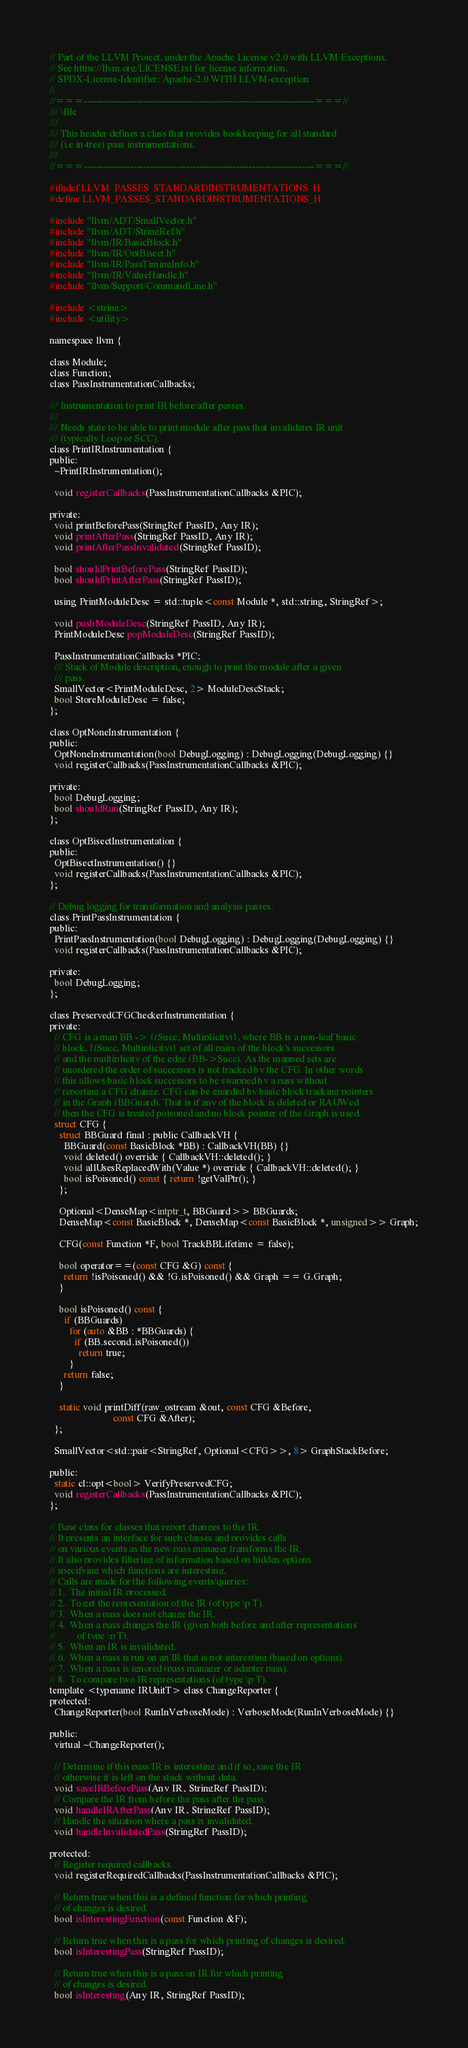Convert code to text. <code><loc_0><loc_0><loc_500><loc_500><_C_>// Part of the LLVM Project, under the Apache License v2.0 with LLVM Exceptions.
// See https://llvm.org/LICENSE.txt for license information.
// SPDX-License-Identifier: Apache-2.0 WITH LLVM-exception
//
//===----------------------------------------------------------------------===//
/// \file
///
/// This header defines a class that provides bookkeeping for all standard
/// (i.e in-tree) pass instrumentations.
///
//===----------------------------------------------------------------------===//

#ifndef LLVM_PASSES_STANDARDINSTRUMENTATIONS_H
#define LLVM_PASSES_STANDARDINSTRUMENTATIONS_H

#include "llvm/ADT/SmallVector.h"
#include "llvm/ADT/StringRef.h"
#include "llvm/IR/BasicBlock.h"
#include "llvm/IR/OptBisect.h"
#include "llvm/IR/PassTimingInfo.h"
#include "llvm/IR/ValueHandle.h"
#include "llvm/Support/CommandLine.h"

#include <string>
#include <utility>

namespace llvm {

class Module;
class Function;
class PassInstrumentationCallbacks;

/// Instrumentation to print IR before/after passes.
///
/// Needs state to be able to print module after pass that invalidates IR unit
/// (typically Loop or SCC).
class PrintIRInstrumentation {
public:
  ~PrintIRInstrumentation();

  void registerCallbacks(PassInstrumentationCallbacks &PIC);

private:
  void printBeforePass(StringRef PassID, Any IR);
  void printAfterPass(StringRef PassID, Any IR);
  void printAfterPassInvalidated(StringRef PassID);

  bool shouldPrintBeforePass(StringRef PassID);
  bool shouldPrintAfterPass(StringRef PassID);

  using PrintModuleDesc = std::tuple<const Module *, std::string, StringRef>;

  void pushModuleDesc(StringRef PassID, Any IR);
  PrintModuleDesc popModuleDesc(StringRef PassID);

  PassInstrumentationCallbacks *PIC;
  /// Stack of Module description, enough to print the module after a given
  /// pass.
  SmallVector<PrintModuleDesc, 2> ModuleDescStack;
  bool StoreModuleDesc = false;
};

class OptNoneInstrumentation {
public:
  OptNoneInstrumentation(bool DebugLogging) : DebugLogging(DebugLogging) {}
  void registerCallbacks(PassInstrumentationCallbacks &PIC);

private:
  bool DebugLogging;
  bool shouldRun(StringRef PassID, Any IR);
};

class OptBisectInstrumentation {
public:
  OptBisectInstrumentation() {}
  void registerCallbacks(PassInstrumentationCallbacks &PIC);
};

// Debug logging for transformation and analysis passes.
class PrintPassInstrumentation {
public:
  PrintPassInstrumentation(bool DebugLogging) : DebugLogging(DebugLogging) {}
  void registerCallbacks(PassInstrumentationCallbacks &PIC);

private:
  bool DebugLogging;
};

class PreservedCFGCheckerInstrumentation {
private:
  // CFG is a map BB -> {(Succ, Multiplicity)}, where BB is a non-leaf basic
  // block, {(Succ, Multiplicity)} set of all pairs of the block's successors
  // and the multiplicity of the edge (BB->Succ). As the mapped sets are
  // unordered the order of successors is not tracked by the CFG. In other words
  // this allows basic block successors to be swapped by a pass without
  // reporting a CFG change. CFG can be guarded by basic block tracking pointers
  // in the Graph (BBGuard). That is if any of the block is deleted or RAUWed
  // then the CFG is treated poisoned and no block pointer of the Graph is used.
  struct CFG {
    struct BBGuard final : public CallbackVH {
      BBGuard(const BasicBlock *BB) : CallbackVH(BB) {}
      void deleted() override { CallbackVH::deleted(); }
      void allUsesReplacedWith(Value *) override { CallbackVH::deleted(); }
      bool isPoisoned() const { return !getValPtr(); }
    };

    Optional<DenseMap<intptr_t, BBGuard>> BBGuards;
    DenseMap<const BasicBlock *, DenseMap<const BasicBlock *, unsigned>> Graph;

    CFG(const Function *F, bool TrackBBLifetime = false);

    bool operator==(const CFG &G) const {
      return !isPoisoned() && !G.isPoisoned() && Graph == G.Graph;
    }

    bool isPoisoned() const {
      if (BBGuards)
        for (auto &BB : *BBGuards) {
          if (BB.second.isPoisoned())
            return true;
        }
      return false;
    }

    static void printDiff(raw_ostream &out, const CFG &Before,
                          const CFG &After);
  };

  SmallVector<std::pair<StringRef, Optional<CFG>>, 8> GraphStackBefore;

public:
  static cl::opt<bool> VerifyPreservedCFG;
  void registerCallbacks(PassInstrumentationCallbacks &PIC);
};

// Base class for classes that report changes to the IR.
// It presents an interface for such classes and provides calls
// on various events as the new pass manager transforms the IR.
// It also provides filtering of information based on hidden options
// specifying which functions are interesting.
// Calls are made for the following events/queries:
// 1.  The initial IR processed.
// 2.  To get the representation of the IR (of type \p T).
// 3.  When a pass does not change the IR.
// 4.  When a pass changes the IR (given both before and after representations
//         of type \p T).
// 5.  When an IR is invalidated.
// 6.  When a pass is run on an IR that is not interesting (based on options).
// 7.  When a pass is ignored (pass manager or adapter pass).
// 8.  To compare two IR representations (of type \p T).
template <typename IRUnitT> class ChangeReporter {
protected:
  ChangeReporter(bool RunInVerboseMode) : VerboseMode(RunInVerboseMode) {}

public:
  virtual ~ChangeReporter();

  // Determine if this pass/IR is interesting and if so, save the IR
  // otherwise it is left on the stack without data.
  void saveIRBeforePass(Any IR, StringRef PassID);
  // Compare the IR from before the pass after the pass.
  void handleIRAfterPass(Any IR, StringRef PassID);
  // Handle the situation where a pass is invalidated.
  void handleInvalidatedPass(StringRef PassID);

protected:
  // Register required callbacks.
  void registerRequiredCallbacks(PassInstrumentationCallbacks &PIC);

  // Return true when this is a defined function for which printing
  // of changes is desired.
  bool isInterestingFunction(const Function &F);

  // Return true when this is a pass for which printing of changes is desired.
  bool isInterestingPass(StringRef PassID);

  // Return true when this is a pass on IR for which printing
  // of changes is desired.
  bool isInteresting(Any IR, StringRef PassID);
</code> 